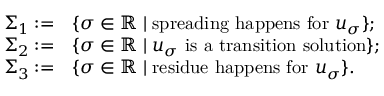<formula> <loc_0><loc_0><loc_500><loc_500>\begin{array} { r l } { \Sigma _ { 1 } \colon = } & { \{ \sigma \in \mathbb { R } \, | \, s p r e a d i n g h a p p e n s f o r u _ { \sigma } \} ; } \\ { \Sigma _ { 2 } \colon = } & { \{ \sigma \in \mathbb { R } \, | \, u _ { \sigma } i s a t r a n s i t i o n s o l u t i o n \} ; } \\ { \Sigma _ { 3 } \colon = } & { \{ \sigma \in \mathbb { R } \, | \, r e s i d u e h a p p e n s f o r u _ { \sigma } \} . } \end{array}</formula> 